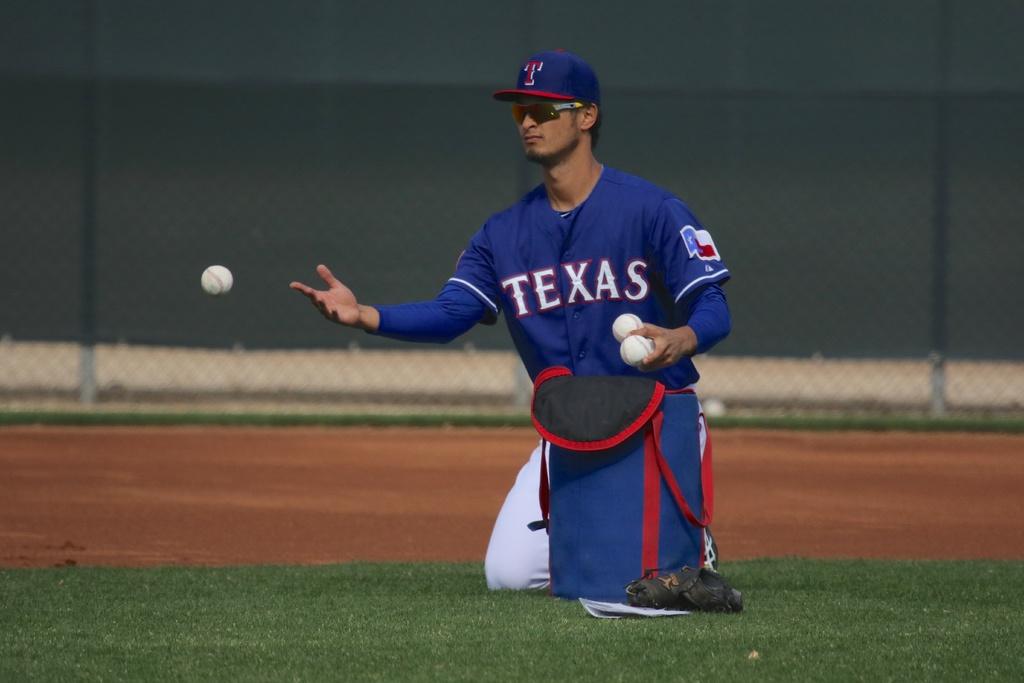What team is he on?
Your answer should be very brief. Texas. 